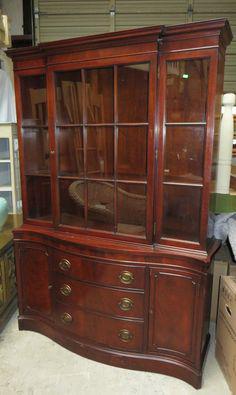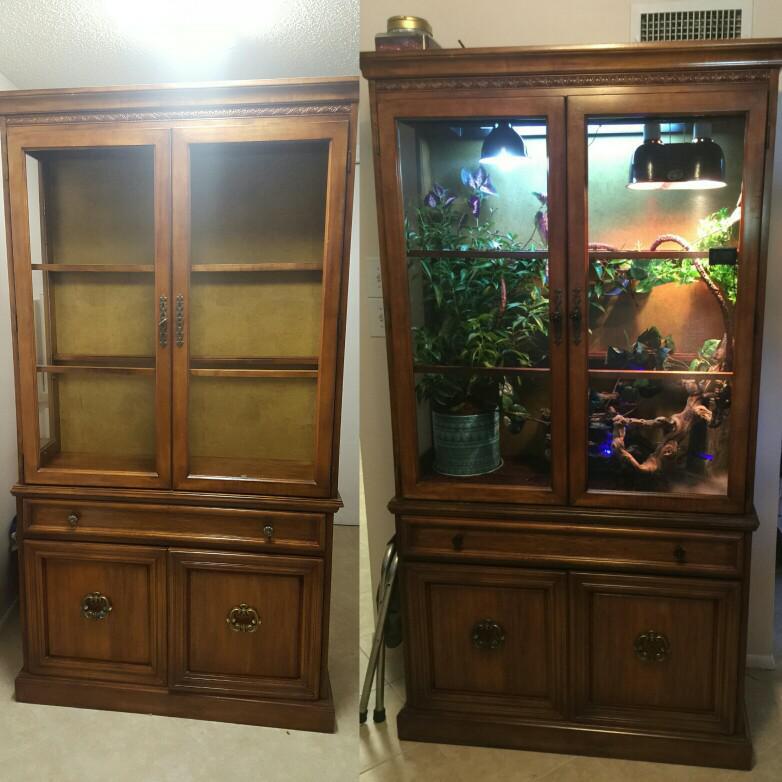The first image is the image on the left, the second image is the image on the right. Analyze the images presented: Is the assertion "There are three vertically stacked drawers in the image on the left." valid? Answer yes or no. Yes. The first image is the image on the left, the second image is the image on the right. Analyze the images presented: Is the assertion "At least one of the cabinets has no legs and sits flush on the floor." valid? Answer yes or no. Yes. 